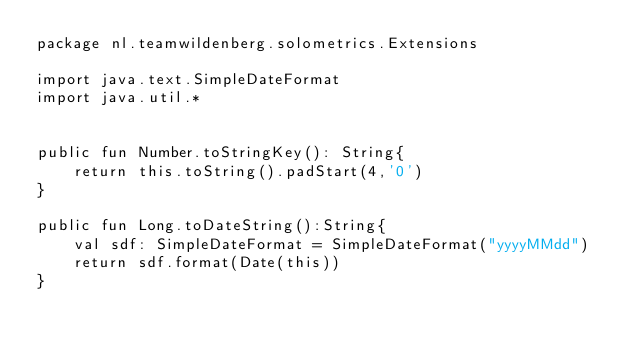<code> <loc_0><loc_0><loc_500><loc_500><_Kotlin_>package nl.teamwildenberg.solometrics.Extensions

import java.text.SimpleDateFormat
import java.util.*


public fun Number.toStringKey(): String{
    return this.toString().padStart(4,'0')
}

public fun Long.toDateString():String{
    val sdf: SimpleDateFormat = SimpleDateFormat("yyyyMMdd")
    return sdf.format(Date(this))
}</code> 